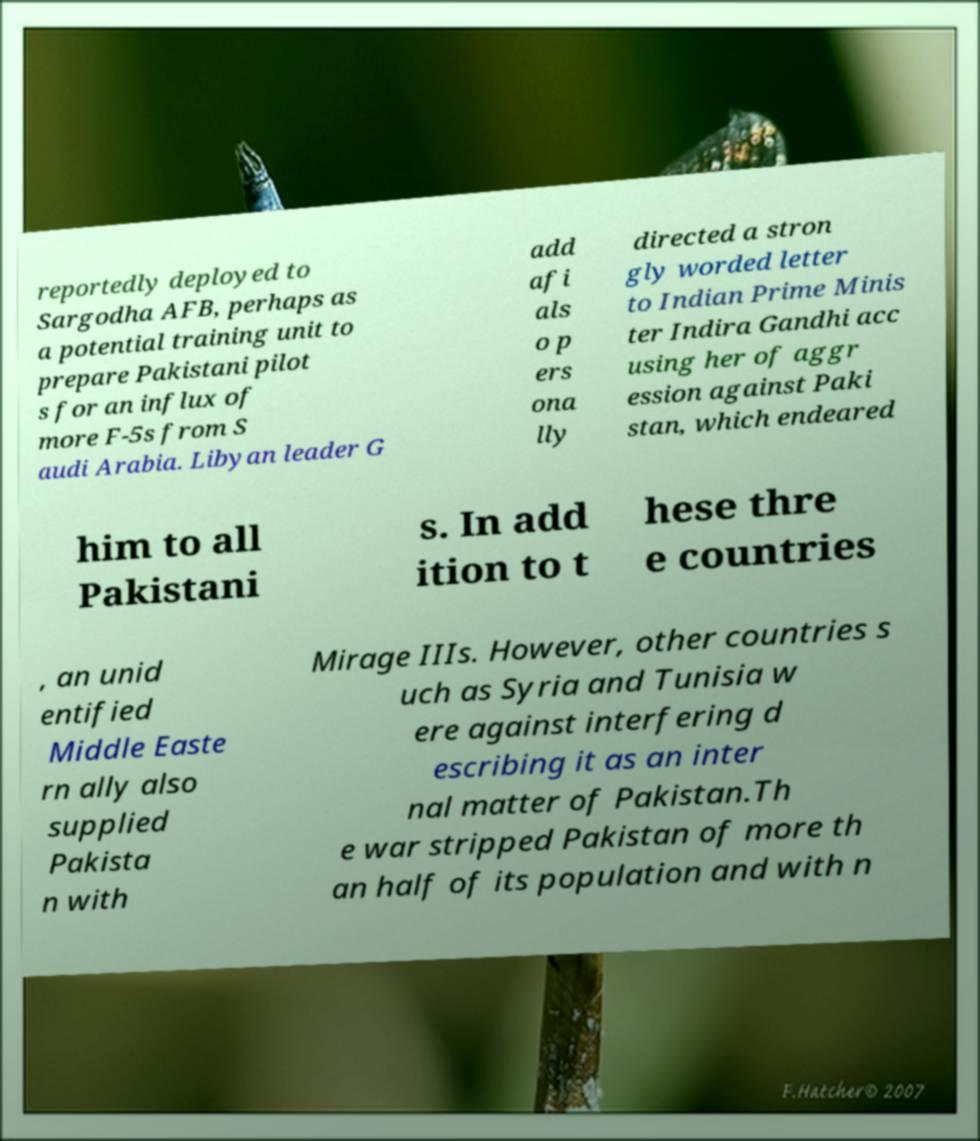Please read and relay the text visible in this image. What does it say? reportedly deployed to Sargodha AFB, perhaps as a potential training unit to prepare Pakistani pilot s for an influx of more F-5s from S audi Arabia. Libyan leader G add afi als o p ers ona lly directed a stron gly worded letter to Indian Prime Minis ter Indira Gandhi acc using her of aggr ession against Paki stan, which endeared him to all Pakistani s. In add ition to t hese thre e countries , an unid entified Middle Easte rn ally also supplied Pakista n with Mirage IIIs. However, other countries s uch as Syria and Tunisia w ere against interfering d escribing it as an inter nal matter of Pakistan.Th e war stripped Pakistan of more th an half of its population and with n 